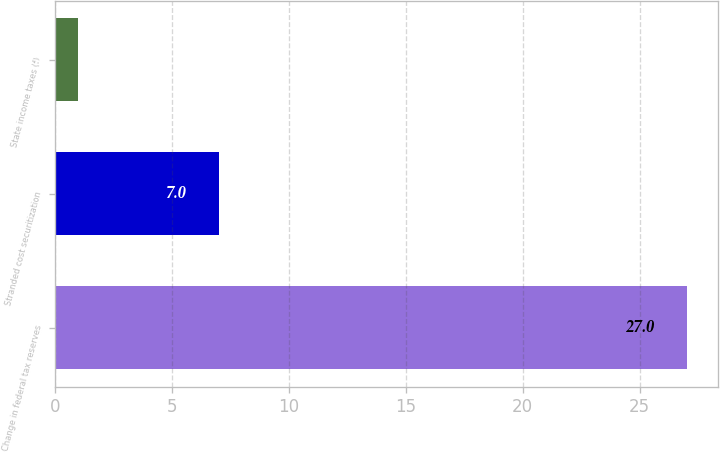<chart> <loc_0><loc_0><loc_500><loc_500><bar_chart><fcel>Change in federal tax reserves<fcel>Stranded cost securitization<fcel>State income taxes (f)<nl><fcel>27<fcel>7<fcel>1<nl></chart> 